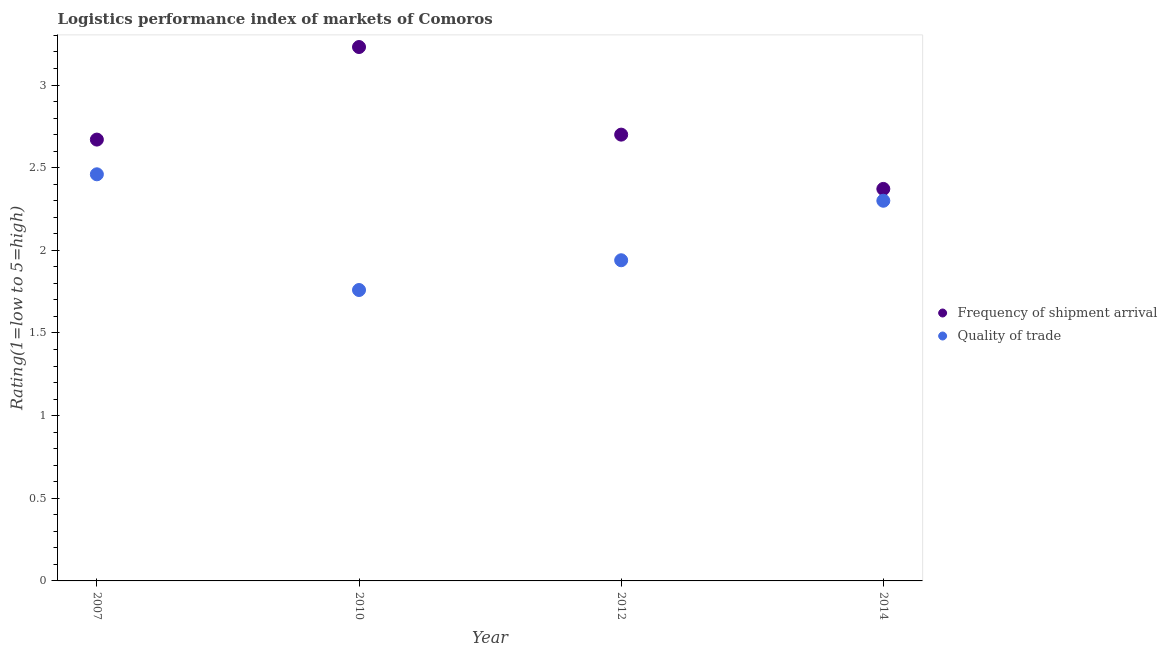Across all years, what is the maximum lpi of frequency of shipment arrival?
Your answer should be very brief. 3.23. Across all years, what is the minimum lpi of frequency of shipment arrival?
Provide a short and direct response. 2.37. In which year was the lpi quality of trade maximum?
Your answer should be very brief. 2007. In which year was the lpi of frequency of shipment arrival minimum?
Your answer should be very brief. 2014. What is the total lpi quality of trade in the graph?
Your answer should be compact. 8.46. What is the difference between the lpi of frequency of shipment arrival in 2007 and that in 2012?
Make the answer very short. -0.03. What is the difference between the lpi of frequency of shipment arrival in 2010 and the lpi quality of trade in 2014?
Your response must be concise. 0.93. What is the average lpi quality of trade per year?
Provide a succinct answer. 2.12. In the year 2010, what is the difference between the lpi of frequency of shipment arrival and lpi quality of trade?
Offer a terse response. 1.47. What is the ratio of the lpi of frequency of shipment arrival in 2007 to that in 2012?
Your answer should be very brief. 0.99. Is the lpi quality of trade in 2010 less than that in 2012?
Make the answer very short. Yes. What is the difference between the highest and the second highest lpi quality of trade?
Offer a very short reply. 0.16. What is the difference between the highest and the lowest lpi of frequency of shipment arrival?
Keep it short and to the point. 0.86. In how many years, is the lpi of frequency of shipment arrival greater than the average lpi of frequency of shipment arrival taken over all years?
Keep it short and to the point. 1. Is the sum of the lpi quality of trade in 2010 and 2012 greater than the maximum lpi of frequency of shipment arrival across all years?
Provide a succinct answer. Yes. Is the lpi quality of trade strictly greater than the lpi of frequency of shipment arrival over the years?
Give a very brief answer. No. How many years are there in the graph?
Your answer should be very brief. 4. What is the difference between two consecutive major ticks on the Y-axis?
Keep it short and to the point. 0.5. Does the graph contain any zero values?
Provide a short and direct response. No. How many legend labels are there?
Keep it short and to the point. 2. How are the legend labels stacked?
Ensure brevity in your answer.  Vertical. What is the title of the graph?
Offer a very short reply. Logistics performance index of markets of Comoros. What is the label or title of the Y-axis?
Offer a very short reply. Rating(1=low to 5=high). What is the Rating(1=low to 5=high) of Frequency of shipment arrival in 2007?
Offer a very short reply. 2.67. What is the Rating(1=low to 5=high) in Quality of trade in 2007?
Make the answer very short. 2.46. What is the Rating(1=low to 5=high) of Frequency of shipment arrival in 2010?
Make the answer very short. 3.23. What is the Rating(1=low to 5=high) in Quality of trade in 2010?
Your answer should be compact. 1.76. What is the Rating(1=low to 5=high) of Frequency of shipment arrival in 2012?
Give a very brief answer. 2.7. What is the Rating(1=low to 5=high) in Quality of trade in 2012?
Ensure brevity in your answer.  1.94. What is the Rating(1=low to 5=high) of Frequency of shipment arrival in 2014?
Your response must be concise. 2.37. Across all years, what is the maximum Rating(1=low to 5=high) in Frequency of shipment arrival?
Offer a very short reply. 3.23. Across all years, what is the maximum Rating(1=low to 5=high) of Quality of trade?
Offer a very short reply. 2.46. Across all years, what is the minimum Rating(1=low to 5=high) in Frequency of shipment arrival?
Your answer should be compact. 2.37. Across all years, what is the minimum Rating(1=low to 5=high) of Quality of trade?
Keep it short and to the point. 1.76. What is the total Rating(1=low to 5=high) in Frequency of shipment arrival in the graph?
Give a very brief answer. 10.97. What is the total Rating(1=low to 5=high) in Quality of trade in the graph?
Your answer should be compact. 8.46. What is the difference between the Rating(1=low to 5=high) of Frequency of shipment arrival in 2007 and that in 2010?
Give a very brief answer. -0.56. What is the difference between the Rating(1=low to 5=high) in Quality of trade in 2007 and that in 2010?
Give a very brief answer. 0.7. What is the difference between the Rating(1=low to 5=high) of Frequency of shipment arrival in 2007 and that in 2012?
Provide a succinct answer. -0.03. What is the difference between the Rating(1=low to 5=high) of Quality of trade in 2007 and that in 2012?
Your response must be concise. 0.52. What is the difference between the Rating(1=low to 5=high) of Frequency of shipment arrival in 2007 and that in 2014?
Make the answer very short. 0.3. What is the difference between the Rating(1=low to 5=high) in Quality of trade in 2007 and that in 2014?
Offer a terse response. 0.16. What is the difference between the Rating(1=low to 5=high) in Frequency of shipment arrival in 2010 and that in 2012?
Make the answer very short. 0.53. What is the difference between the Rating(1=low to 5=high) in Quality of trade in 2010 and that in 2012?
Offer a very short reply. -0.18. What is the difference between the Rating(1=low to 5=high) of Frequency of shipment arrival in 2010 and that in 2014?
Your response must be concise. 0.86. What is the difference between the Rating(1=low to 5=high) in Quality of trade in 2010 and that in 2014?
Keep it short and to the point. -0.54. What is the difference between the Rating(1=low to 5=high) in Frequency of shipment arrival in 2012 and that in 2014?
Your answer should be compact. 0.33. What is the difference between the Rating(1=low to 5=high) of Quality of trade in 2012 and that in 2014?
Provide a succinct answer. -0.36. What is the difference between the Rating(1=low to 5=high) in Frequency of shipment arrival in 2007 and the Rating(1=low to 5=high) in Quality of trade in 2010?
Provide a succinct answer. 0.91. What is the difference between the Rating(1=low to 5=high) in Frequency of shipment arrival in 2007 and the Rating(1=low to 5=high) in Quality of trade in 2012?
Offer a very short reply. 0.73. What is the difference between the Rating(1=low to 5=high) of Frequency of shipment arrival in 2007 and the Rating(1=low to 5=high) of Quality of trade in 2014?
Provide a succinct answer. 0.37. What is the difference between the Rating(1=low to 5=high) in Frequency of shipment arrival in 2010 and the Rating(1=low to 5=high) in Quality of trade in 2012?
Keep it short and to the point. 1.29. What is the difference between the Rating(1=low to 5=high) of Frequency of shipment arrival in 2010 and the Rating(1=low to 5=high) of Quality of trade in 2014?
Make the answer very short. 0.93. What is the average Rating(1=low to 5=high) of Frequency of shipment arrival per year?
Provide a short and direct response. 2.74. What is the average Rating(1=low to 5=high) of Quality of trade per year?
Give a very brief answer. 2.12. In the year 2007, what is the difference between the Rating(1=low to 5=high) in Frequency of shipment arrival and Rating(1=low to 5=high) in Quality of trade?
Your response must be concise. 0.21. In the year 2010, what is the difference between the Rating(1=low to 5=high) in Frequency of shipment arrival and Rating(1=low to 5=high) in Quality of trade?
Make the answer very short. 1.47. In the year 2012, what is the difference between the Rating(1=low to 5=high) of Frequency of shipment arrival and Rating(1=low to 5=high) of Quality of trade?
Your response must be concise. 0.76. In the year 2014, what is the difference between the Rating(1=low to 5=high) of Frequency of shipment arrival and Rating(1=low to 5=high) of Quality of trade?
Keep it short and to the point. 0.07. What is the ratio of the Rating(1=low to 5=high) in Frequency of shipment arrival in 2007 to that in 2010?
Make the answer very short. 0.83. What is the ratio of the Rating(1=low to 5=high) of Quality of trade in 2007 to that in 2010?
Give a very brief answer. 1.4. What is the ratio of the Rating(1=low to 5=high) in Frequency of shipment arrival in 2007 to that in 2012?
Offer a terse response. 0.99. What is the ratio of the Rating(1=low to 5=high) in Quality of trade in 2007 to that in 2012?
Provide a succinct answer. 1.27. What is the ratio of the Rating(1=low to 5=high) of Frequency of shipment arrival in 2007 to that in 2014?
Offer a very short reply. 1.13. What is the ratio of the Rating(1=low to 5=high) in Quality of trade in 2007 to that in 2014?
Your response must be concise. 1.07. What is the ratio of the Rating(1=low to 5=high) of Frequency of shipment arrival in 2010 to that in 2012?
Keep it short and to the point. 1.2. What is the ratio of the Rating(1=low to 5=high) of Quality of trade in 2010 to that in 2012?
Ensure brevity in your answer.  0.91. What is the ratio of the Rating(1=low to 5=high) of Frequency of shipment arrival in 2010 to that in 2014?
Give a very brief answer. 1.36. What is the ratio of the Rating(1=low to 5=high) of Quality of trade in 2010 to that in 2014?
Offer a very short reply. 0.77. What is the ratio of the Rating(1=low to 5=high) in Frequency of shipment arrival in 2012 to that in 2014?
Make the answer very short. 1.14. What is the ratio of the Rating(1=low to 5=high) in Quality of trade in 2012 to that in 2014?
Your answer should be very brief. 0.84. What is the difference between the highest and the second highest Rating(1=low to 5=high) in Frequency of shipment arrival?
Ensure brevity in your answer.  0.53. What is the difference between the highest and the second highest Rating(1=low to 5=high) in Quality of trade?
Make the answer very short. 0.16. What is the difference between the highest and the lowest Rating(1=low to 5=high) in Frequency of shipment arrival?
Give a very brief answer. 0.86. 